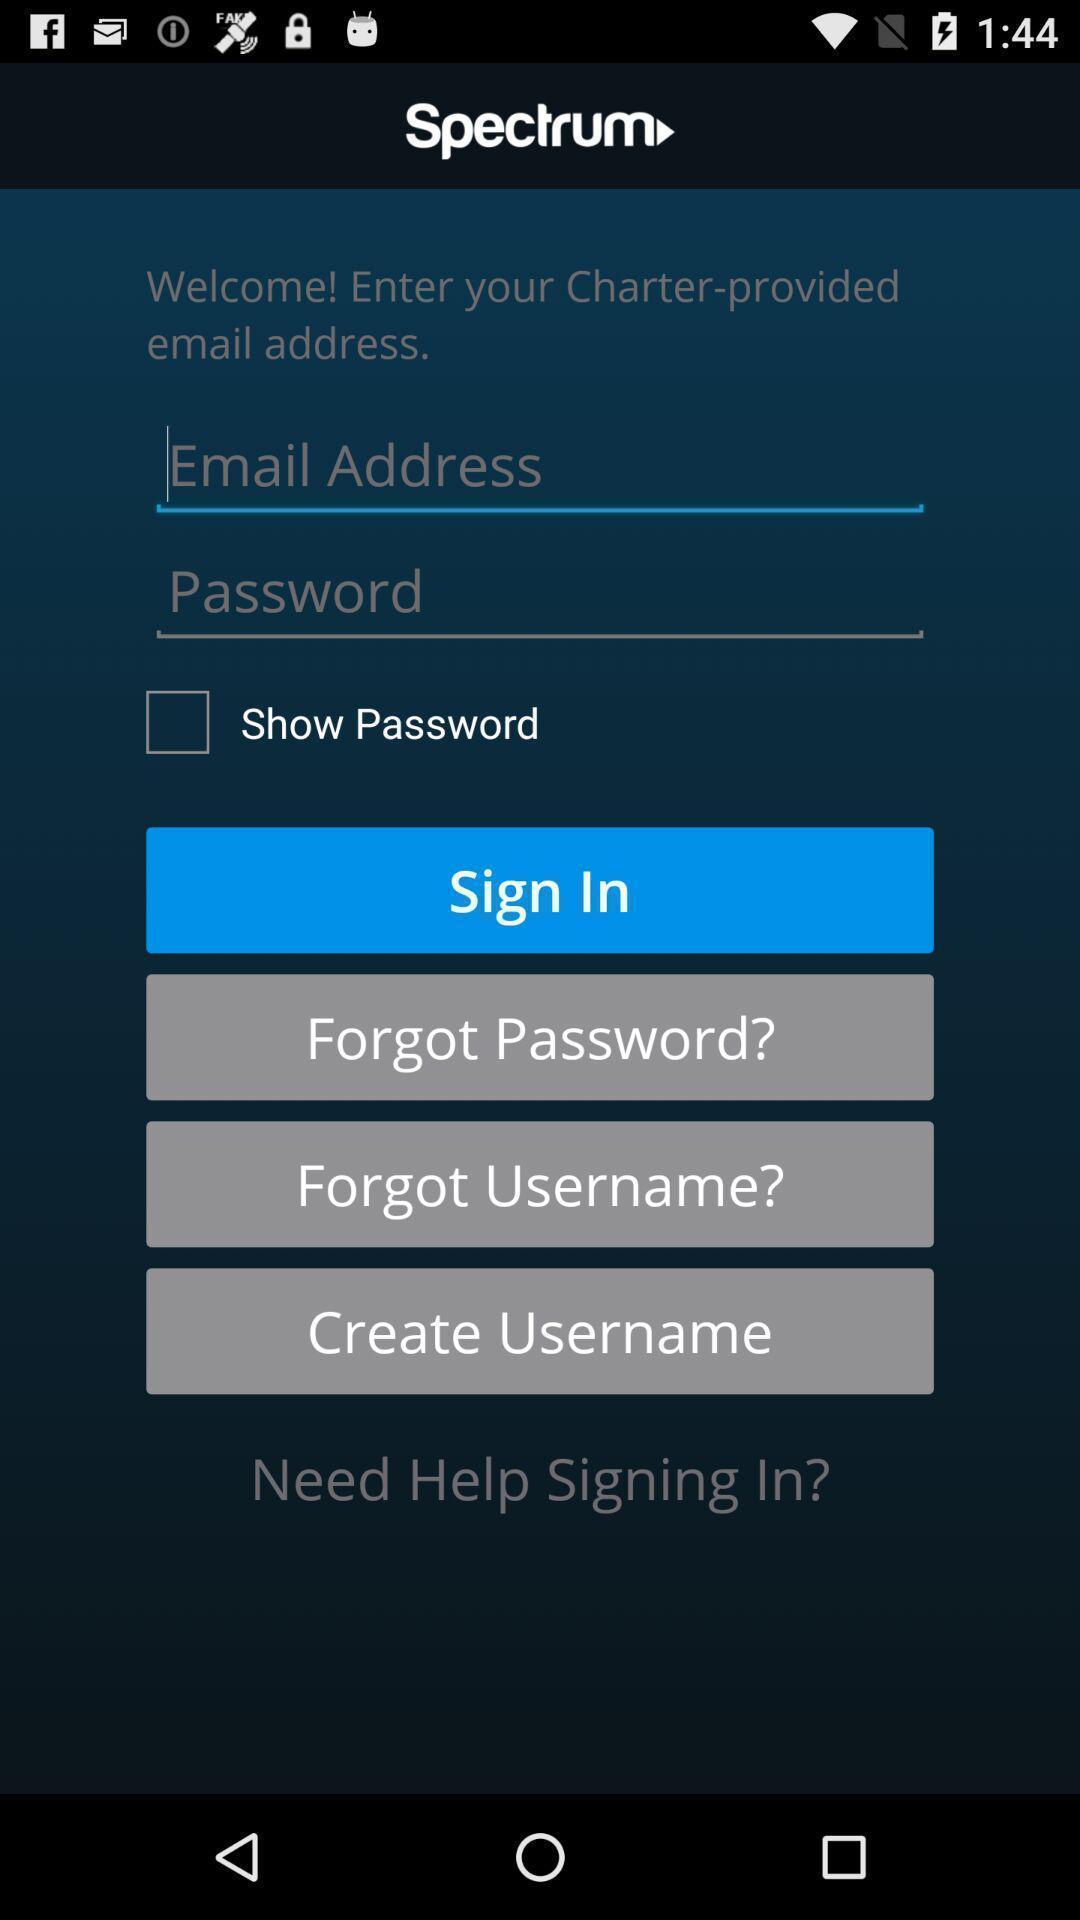Tell me about the visual elements in this screen capture. Welcome page with multiple options. 